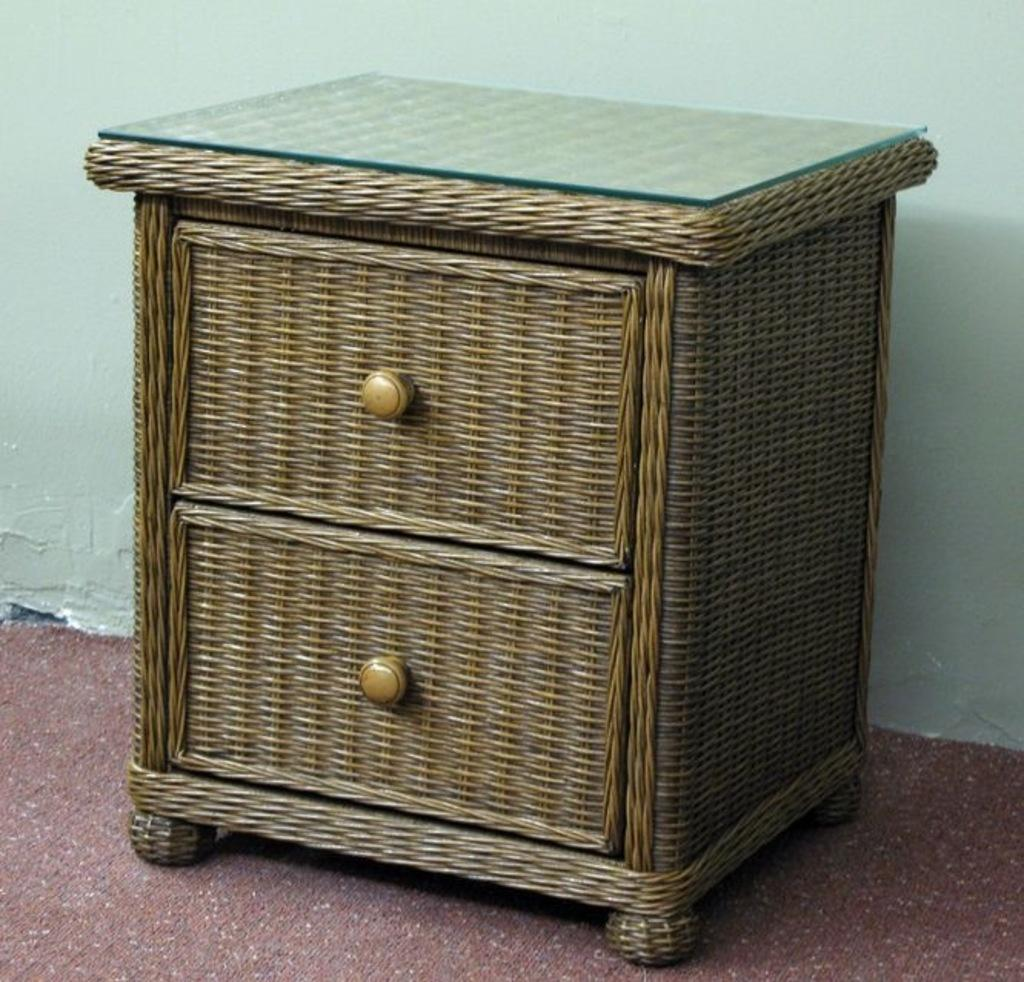What type of furniture is present in the image? There is a wooden dresser in the image. What is placed on top of the wooden dresser? There is a glass sheet on the dresser. What can be seen beneath the wooden dresser? The floor is visible in the image. What is the background of the image? There is a wall in the image. What type of mine is visible in the image? There is no mine present in the image. How does the kettle contribute to the aesthetic of the image? There is no kettle present in the image. 